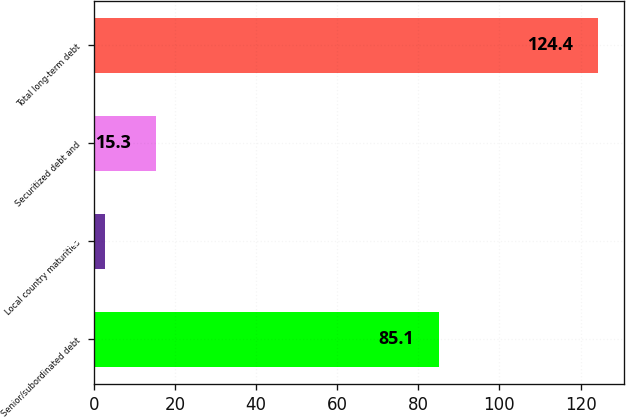Convert chart. <chart><loc_0><loc_0><loc_500><loc_500><bar_chart><fcel>Senior/subordinated debt<fcel>Local country maturities<fcel>Securitized debt and<fcel>Total long-term debt<nl><fcel>85.1<fcel>2.9<fcel>15.3<fcel>124.4<nl></chart> 